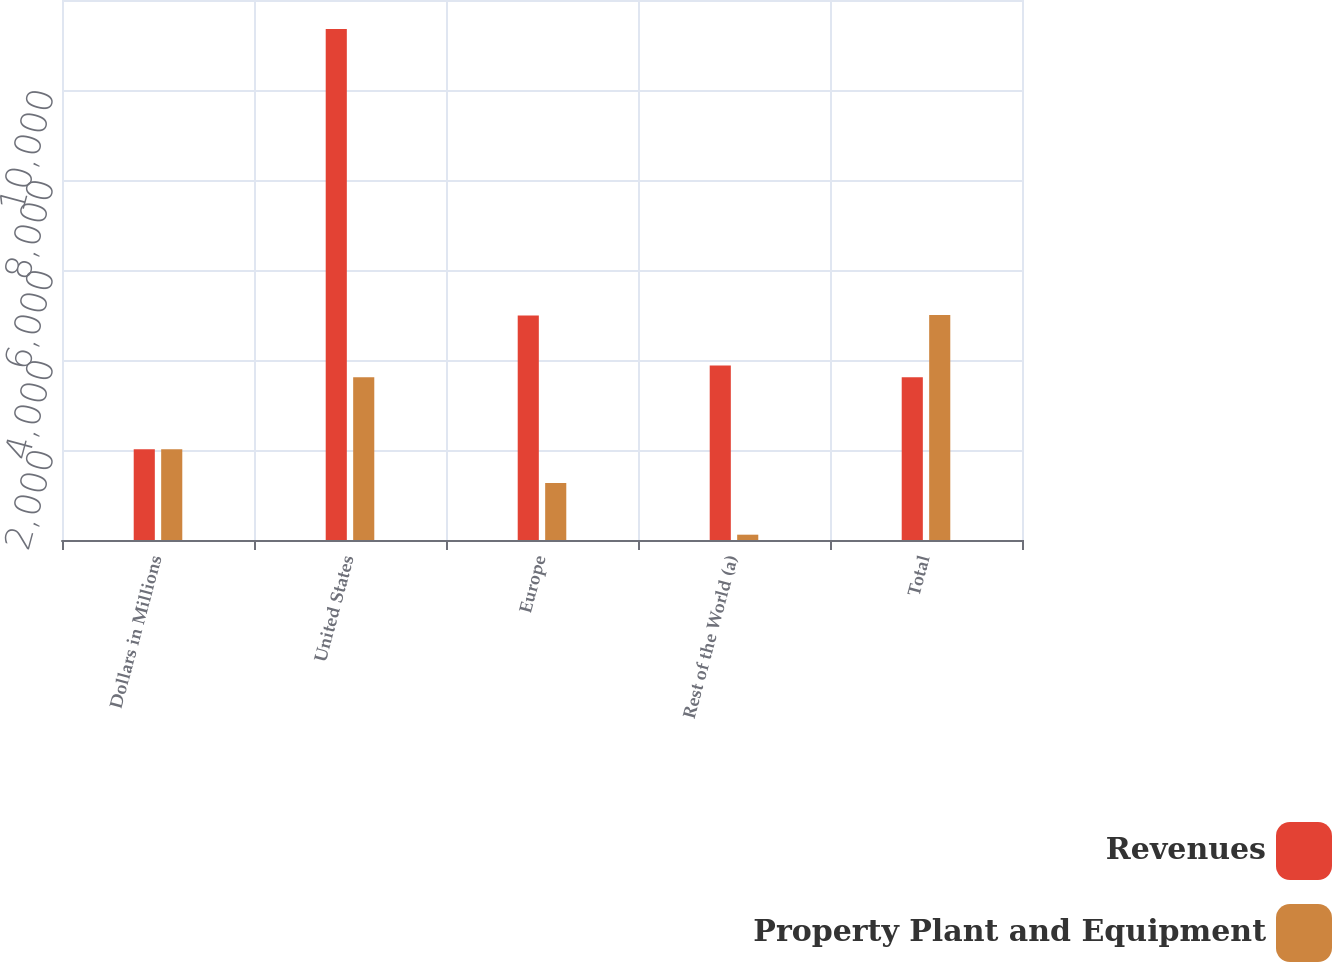Convert chart to OTSL. <chart><loc_0><loc_0><loc_500><loc_500><stacked_bar_chart><ecel><fcel>Dollars in Millions<fcel>United States<fcel>Europe<fcel>Rest of the World (a)<fcel>Total<nl><fcel>Revenues<fcel>2017<fcel>11358<fcel>4988<fcel>3877<fcel>3617<nl><fcel>Property Plant and Equipment<fcel>2017<fcel>3617<fcel>1266<fcel>118<fcel>5001<nl></chart> 